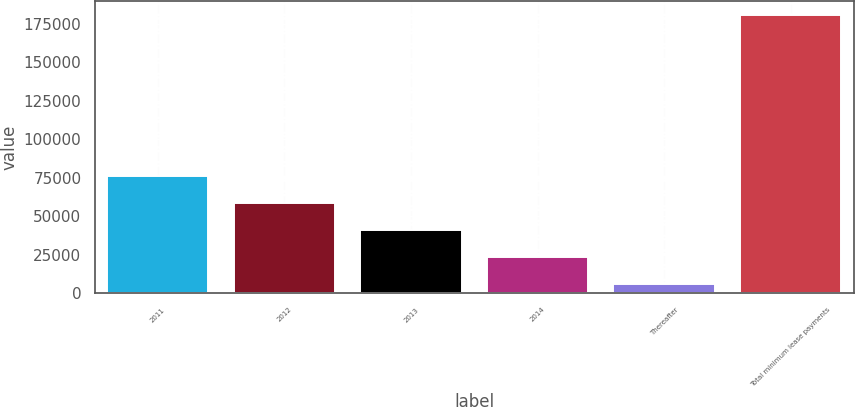Convert chart. <chart><loc_0><loc_0><loc_500><loc_500><bar_chart><fcel>2011<fcel>2012<fcel>2013<fcel>2014<fcel>Thereafter<fcel>Total minimum lease payments<nl><fcel>75956.2<fcel>58460.4<fcel>40964.6<fcel>23468.8<fcel>5973<fcel>180931<nl></chart> 